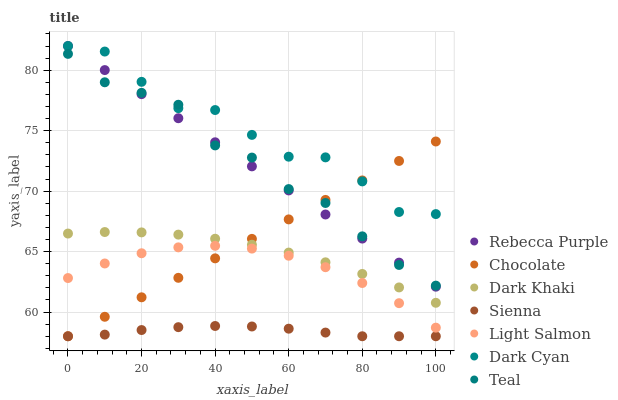Does Sienna have the minimum area under the curve?
Answer yes or no. Yes. Does Dark Cyan have the maximum area under the curve?
Answer yes or no. Yes. Does Light Salmon have the minimum area under the curve?
Answer yes or no. No. Does Light Salmon have the maximum area under the curve?
Answer yes or no. No. Is Chocolate the smoothest?
Answer yes or no. Yes. Is Dark Cyan the roughest?
Answer yes or no. Yes. Is Light Salmon the smoothest?
Answer yes or no. No. Is Light Salmon the roughest?
Answer yes or no. No. Does Sienna have the lowest value?
Answer yes or no. Yes. Does Light Salmon have the lowest value?
Answer yes or no. No. Does Dark Cyan have the highest value?
Answer yes or no. Yes. Does Light Salmon have the highest value?
Answer yes or no. No. Is Dark Khaki less than Rebecca Purple?
Answer yes or no. Yes. Is Teal greater than Sienna?
Answer yes or no. Yes. Does Chocolate intersect Dark Cyan?
Answer yes or no. Yes. Is Chocolate less than Dark Cyan?
Answer yes or no. No. Is Chocolate greater than Dark Cyan?
Answer yes or no. No. Does Dark Khaki intersect Rebecca Purple?
Answer yes or no. No. 